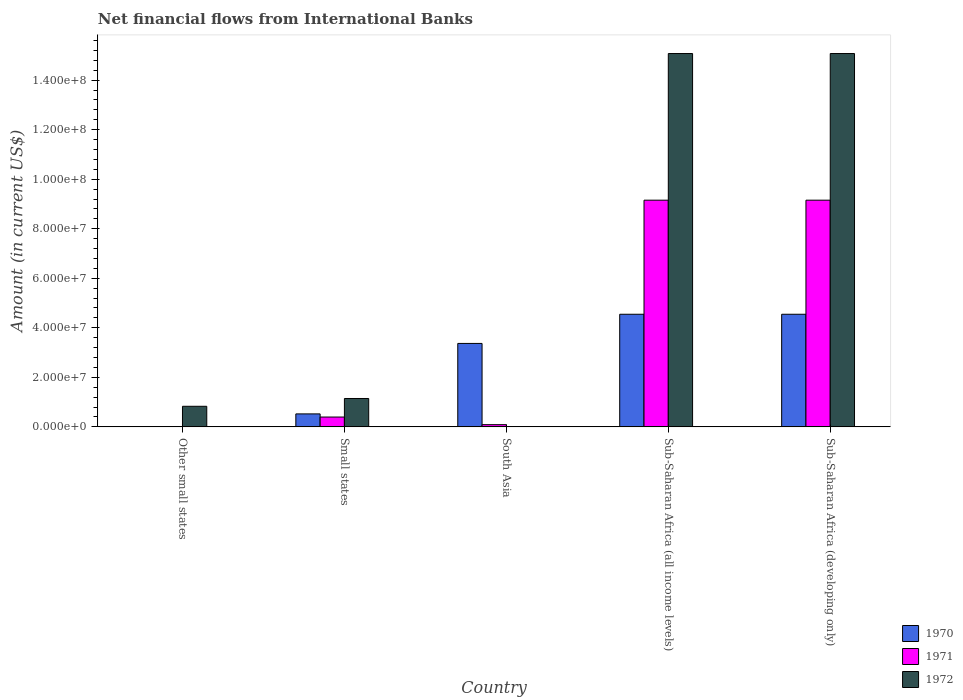Are the number of bars per tick equal to the number of legend labels?
Your answer should be compact. No. Are the number of bars on each tick of the X-axis equal?
Your answer should be very brief. No. How many bars are there on the 4th tick from the left?
Keep it short and to the point. 3. What is the label of the 2nd group of bars from the left?
Provide a succinct answer. Small states. In how many cases, is the number of bars for a given country not equal to the number of legend labels?
Offer a very short reply. 2. What is the net financial aid flows in 1971 in South Asia?
Ensure brevity in your answer.  8.91e+05. Across all countries, what is the maximum net financial aid flows in 1971?
Your answer should be very brief. 9.15e+07. Across all countries, what is the minimum net financial aid flows in 1971?
Your answer should be very brief. 0. In which country was the net financial aid flows in 1970 maximum?
Offer a terse response. Sub-Saharan Africa (all income levels). What is the total net financial aid flows in 1971 in the graph?
Your response must be concise. 1.88e+08. What is the difference between the net financial aid flows in 1970 in South Asia and that in Sub-Saharan Africa (all income levels)?
Keep it short and to the point. -1.18e+07. What is the difference between the net financial aid flows in 1972 in Small states and the net financial aid flows in 1970 in Sub-Saharan Africa (all income levels)?
Ensure brevity in your answer.  -3.40e+07. What is the average net financial aid flows in 1972 per country?
Provide a short and direct response. 6.42e+07. What is the difference between the net financial aid flows of/in 1971 and net financial aid flows of/in 1972 in Small states?
Offer a terse response. -7.49e+06. What is the ratio of the net financial aid flows in 1971 in Small states to that in Sub-Saharan Africa (all income levels)?
Offer a very short reply. 0.04. Is the net financial aid flows in 1970 in Small states less than that in South Asia?
Your response must be concise. Yes. Is the difference between the net financial aid flows in 1971 in Small states and Sub-Saharan Africa (all income levels) greater than the difference between the net financial aid flows in 1972 in Small states and Sub-Saharan Africa (all income levels)?
Your answer should be compact. Yes. What is the difference between the highest and the second highest net financial aid flows in 1970?
Provide a succinct answer. 1.18e+07. What is the difference between the highest and the lowest net financial aid flows in 1972?
Your answer should be very brief. 1.51e+08. In how many countries, is the net financial aid flows in 1971 greater than the average net financial aid flows in 1971 taken over all countries?
Offer a terse response. 2. Is the sum of the net financial aid flows in 1972 in Other small states and Sub-Saharan Africa (all income levels) greater than the maximum net financial aid flows in 1970 across all countries?
Your response must be concise. Yes. How many bars are there?
Provide a succinct answer. 12. Are all the bars in the graph horizontal?
Keep it short and to the point. No. Are the values on the major ticks of Y-axis written in scientific E-notation?
Give a very brief answer. Yes. How many legend labels are there?
Your answer should be very brief. 3. What is the title of the graph?
Give a very brief answer. Net financial flows from International Banks. Does "1990" appear as one of the legend labels in the graph?
Offer a very short reply. No. What is the Amount (in current US$) of 1971 in Other small states?
Give a very brief answer. 0. What is the Amount (in current US$) of 1972 in Other small states?
Provide a short and direct response. 8.31e+06. What is the Amount (in current US$) of 1970 in Small states?
Your response must be concise. 5.24e+06. What is the Amount (in current US$) in 1971 in Small states?
Provide a short and direct response. 3.97e+06. What is the Amount (in current US$) in 1972 in Small states?
Give a very brief answer. 1.15e+07. What is the Amount (in current US$) of 1970 in South Asia?
Offer a very short reply. 3.37e+07. What is the Amount (in current US$) of 1971 in South Asia?
Offer a very short reply. 8.91e+05. What is the Amount (in current US$) of 1972 in South Asia?
Make the answer very short. 0. What is the Amount (in current US$) in 1970 in Sub-Saharan Africa (all income levels)?
Provide a succinct answer. 4.55e+07. What is the Amount (in current US$) of 1971 in Sub-Saharan Africa (all income levels)?
Keep it short and to the point. 9.15e+07. What is the Amount (in current US$) of 1972 in Sub-Saharan Africa (all income levels)?
Make the answer very short. 1.51e+08. What is the Amount (in current US$) of 1970 in Sub-Saharan Africa (developing only)?
Provide a succinct answer. 4.55e+07. What is the Amount (in current US$) in 1971 in Sub-Saharan Africa (developing only)?
Offer a very short reply. 9.15e+07. What is the Amount (in current US$) in 1972 in Sub-Saharan Africa (developing only)?
Offer a very short reply. 1.51e+08. Across all countries, what is the maximum Amount (in current US$) in 1970?
Make the answer very short. 4.55e+07. Across all countries, what is the maximum Amount (in current US$) of 1971?
Your answer should be compact. 9.15e+07. Across all countries, what is the maximum Amount (in current US$) in 1972?
Your answer should be very brief. 1.51e+08. Across all countries, what is the minimum Amount (in current US$) of 1970?
Your answer should be very brief. 0. What is the total Amount (in current US$) in 1970 in the graph?
Your response must be concise. 1.30e+08. What is the total Amount (in current US$) of 1971 in the graph?
Offer a very short reply. 1.88e+08. What is the total Amount (in current US$) of 1972 in the graph?
Offer a very short reply. 3.21e+08. What is the difference between the Amount (in current US$) of 1972 in Other small states and that in Small states?
Ensure brevity in your answer.  -3.15e+06. What is the difference between the Amount (in current US$) of 1972 in Other small states and that in Sub-Saharan Africa (all income levels)?
Keep it short and to the point. -1.42e+08. What is the difference between the Amount (in current US$) of 1972 in Other small states and that in Sub-Saharan Africa (developing only)?
Make the answer very short. -1.42e+08. What is the difference between the Amount (in current US$) of 1970 in Small states and that in South Asia?
Ensure brevity in your answer.  -2.85e+07. What is the difference between the Amount (in current US$) of 1971 in Small states and that in South Asia?
Offer a terse response. 3.08e+06. What is the difference between the Amount (in current US$) in 1970 in Small states and that in Sub-Saharan Africa (all income levels)?
Offer a very short reply. -4.02e+07. What is the difference between the Amount (in current US$) of 1971 in Small states and that in Sub-Saharan Africa (all income levels)?
Provide a short and direct response. -8.76e+07. What is the difference between the Amount (in current US$) of 1972 in Small states and that in Sub-Saharan Africa (all income levels)?
Give a very brief answer. -1.39e+08. What is the difference between the Amount (in current US$) of 1970 in Small states and that in Sub-Saharan Africa (developing only)?
Your answer should be very brief. -4.02e+07. What is the difference between the Amount (in current US$) of 1971 in Small states and that in Sub-Saharan Africa (developing only)?
Offer a terse response. -8.76e+07. What is the difference between the Amount (in current US$) of 1972 in Small states and that in Sub-Saharan Africa (developing only)?
Your answer should be very brief. -1.39e+08. What is the difference between the Amount (in current US$) of 1970 in South Asia and that in Sub-Saharan Africa (all income levels)?
Give a very brief answer. -1.18e+07. What is the difference between the Amount (in current US$) of 1971 in South Asia and that in Sub-Saharan Africa (all income levels)?
Offer a terse response. -9.06e+07. What is the difference between the Amount (in current US$) of 1970 in South Asia and that in Sub-Saharan Africa (developing only)?
Offer a very short reply. -1.18e+07. What is the difference between the Amount (in current US$) of 1971 in South Asia and that in Sub-Saharan Africa (developing only)?
Your answer should be very brief. -9.06e+07. What is the difference between the Amount (in current US$) in 1970 in Sub-Saharan Africa (all income levels) and that in Sub-Saharan Africa (developing only)?
Give a very brief answer. 0. What is the difference between the Amount (in current US$) of 1972 in Sub-Saharan Africa (all income levels) and that in Sub-Saharan Africa (developing only)?
Your answer should be compact. 0. What is the difference between the Amount (in current US$) of 1970 in Small states and the Amount (in current US$) of 1971 in South Asia?
Provide a short and direct response. 4.34e+06. What is the difference between the Amount (in current US$) in 1970 in Small states and the Amount (in current US$) in 1971 in Sub-Saharan Africa (all income levels)?
Give a very brief answer. -8.63e+07. What is the difference between the Amount (in current US$) of 1970 in Small states and the Amount (in current US$) of 1972 in Sub-Saharan Africa (all income levels)?
Provide a succinct answer. -1.45e+08. What is the difference between the Amount (in current US$) in 1971 in Small states and the Amount (in current US$) in 1972 in Sub-Saharan Africa (all income levels)?
Keep it short and to the point. -1.47e+08. What is the difference between the Amount (in current US$) in 1970 in Small states and the Amount (in current US$) in 1971 in Sub-Saharan Africa (developing only)?
Give a very brief answer. -8.63e+07. What is the difference between the Amount (in current US$) of 1970 in Small states and the Amount (in current US$) of 1972 in Sub-Saharan Africa (developing only)?
Give a very brief answer. -1.45e+08. What is the difference between the Amount (in current US$) of 1971 in Small states and the Amount (in current US$) of 1972 in Sub-Saharan Africa (developing only)?
Your response must be concise. -1.47e+08. What is the difference between the Amount (in current US$) in 1970 in South Asia and the Amount (in current US$) in 1971 in Sub-Saharan Africa (all income levels)?
Keep it short and to the point. -5.78e+07. What is the difference between the Amount (in current US$) of 1970 in South Asia and the Amount (in current US$) of 1972 in Sub-Saharan Africa (all income levels)?
Provide a succinct answer. -1.17e+08. What is the difference between the Amount (in current US$) in 1971 in South Asia and the Amount (in current US$) in 1972 in Sub-Saharan Africa (all income levels)?
Your answer should be very brief. -1.50e+08. What is the difference between the Amount (in current US$) of 1970 in South Asia and the Amount (in current US$) of 1971 in Sub-Saharan Africa (developing only)?
Ensure brevity in your answer.  -5.78e+07. What is the difference between the Amount (in current US$) in 1970 in South Asia and the Amount (in current US$) in 1972 in Sub-Saharan Africa (developing only)?
Your answer should be very brief. -1.17e+08. What is the difference between the Amount (in current US$) in 1971 in South Asia and the Amount (in current US$) in 1972 in Sub-Saharan Africa (developing only)?
Your answer should be compact. -1.50e+08. What is the difference between the Amount (in current US$) in 1970 in Sub-Saharan Africa (all income levels) and the Amount (in current US$) in 1971 in Sub-Saharan Africa (developing only)?
Your answer should be compact. -4.61e+07. What is the difference between the Amount (in current US$) of 1970 in Sub-Saharan Africa (all income levels) and the Amount (in current US$) of 1972 in Sub-Saharan Africa (developing only)?
Your answer should be compact. -1.05e+08. What is the difference between the Amount (in current US$) of 1971 in Sub-Saharan Africa (all income levels) and the Amount (in current US$) of 1972 in Sub-Saharan Africa (developing only)?
Provide a succinct answer. -5.92e+07. What is the average Amount (in current US$) of 1970 per country?
Offer a terse response. 2.60e+07. What is the average Amount (in current US$) of 1971 per country?
Provide a succinct answer. 3.76e+07. What is the average Amount (in current US$) of 1972 per country?
Offer a terse response. 6.42e+07. What is the difference between the Amount (in current US$) in 1970 and Amount (in current US$) in 1971 in Small states?
Your answer should be very brief. 1.27e+06. What is the difference between the Amount (in current US$) of 1970 and Amount (in current US$) of 1972 in Small states?
Keep it short and to the point. -6.22e+06. What is the difference between the Amount (in current US$) in 1971 and Amount (in current US$) in 1972 in Small states?
Make the answer very short. -7.49e+06. What is the difference between the Amount (in current US$) in 1970 and Amount (in current US$) in 1971 in South Asia?
Your answer should be very brief. 3.28e+07. What is the difference between the Amount (in current US$) in 1970 and Amount (in current US$) in 1971 in Sub-Saharan Africa (all income levels)?
Offer a very short reply. -4.61e+07. What is the difference between the Amount (in current US$) in 1970 and Amount (in current US$) in 1972 in Sub-Saharan Africa (all income levels)?
Your answer should be compact. -1.05e+08. What is the difference between the Amount (in current US$) in 1971 and Amount (in current US$) in 1972 in Sub-Saharan Africa (all income levels)?
Offer a terse response. -5.92e+07. What is the difference between the Amount (in current US$) in 1970 and Amount (in current US$) in 1971 in Sub-Saharan Africa (developing only)?
Ensure brevity in your answer.  -4.61e+07. What is the difference between the Amount (in current US$) of 1970 and Amount (in current US$) of 1972 in Sub-Saharan Africa (developing only)?
Keep it short and to the point. -1.05e+08. What is the difference between the Amount (in current US$) of 1971 and Amount (in current US$) of 1972 in Sub-Saharan Africa (developing only)?
Offer a terse response. -5.92e+07. What is the ratio of the Amount (in current US$) in 1972 in Other small states to that in Small states?
Ensure brevity in your answer.  0.73. What is the ratio of the Amount (in current US$) of 1972 in Other small states to that in Sub-Saharan Africa (all income levels)?
Make the answer very short. 0.06. What is the ratio of the Amount (in current US$) of 1972 in Other small states to that in Sub-Saharan Africa (developing only)?
Provide a short and direct response. 0.06. What is the ratio of the Amount (in current US$) of 1970 in Small states to that in South Asia?
Keep it short and to the point. 0.16. What is the ratio of the Amount (in current US$) in 1971 in Small states to that in South Asia?
Ensure brevity in your answer.  4.45. What is the ratio of the Amount (in current US$) in 1970 in Small states to that in Sub-Saharan Africa (all income levels)?
Provide a short and direct response. 0.12. What is the ratio of the Amount (in current US$) of 1971 in Small states to that in Sub-Saharan Africa (all income levels)?
Provide a succinct answer. 0.04. What is the ratio of the Amount (in current US$) of 1972 in Small states to that in Sub-Saharan Africa (all income levels)?
Give a very brief answer. 0.08. What is the ratio of the Amount (in current US$) in 1970 in Small states to that in Sub-Saharan Africa (developing only)?
Offer a terse response. 0.12. What is the ratio of the Amount (in current US$) in 1971 in Small states to that in Sub-Saharan Africa (developing only)?
Offer a terse response. 0.04. What is the ratio of the Amount (in current US$) of 1972 in Small states to that in Sub-Saharan Africa (developing only)?
Offer a terse response. 0.08. What is the ratio of the Amount (in current US$) of 1970 in South Asia to that in Sub-Saharan Africa (all income levels)?
Provide a succinct answer. 0.74. What is the ratio of the Amount (in current US$) in 1971 in South Asia to that in Sub-Saharan Africa (all income levels)?
Offer a terse response. 0.01. What is the ratio of the Amount (in current US$) of 1970 in South Asia to that in Sub-Saharan Africa (developing only)?
Give a very brief answer. 0.74. What is the ratio of the Amount (in current US$) in 1971 in South Asia to that in Sub-Saharan Africa (developing only)?
Your answer should be very brief. 0.01. What is the ratio of the Amount (in current US$) in 1970 in Sub-Saharan Africa (all income levels) to that in Sub-Saharan Africa (developing only)?
Your answer should be compact. 1. What is the ratio of the Amount (in current US$) of 1971 in Sub-Saharan Africa (all income levels) to that in Sub-Saharan Africa (developing only)?
Offer a terse response. 1. What is the difference between the highest and the second highest Amount (in current US$) in 1970?
Offer a terse response. 0. What is the difference between the highest and the lowest Amount (in current US$) in 1970?
Your answer should be compact. 4.55e+07. What is the difference between the highest and the lowest Amount (in current US$) in 1971?
Your answer should be very brief. 9.15e+07. What is the difference between the highest and the lowest Amount (in current US$) of 1972?
Ensure brevity in your answer.  1.51e+08. 